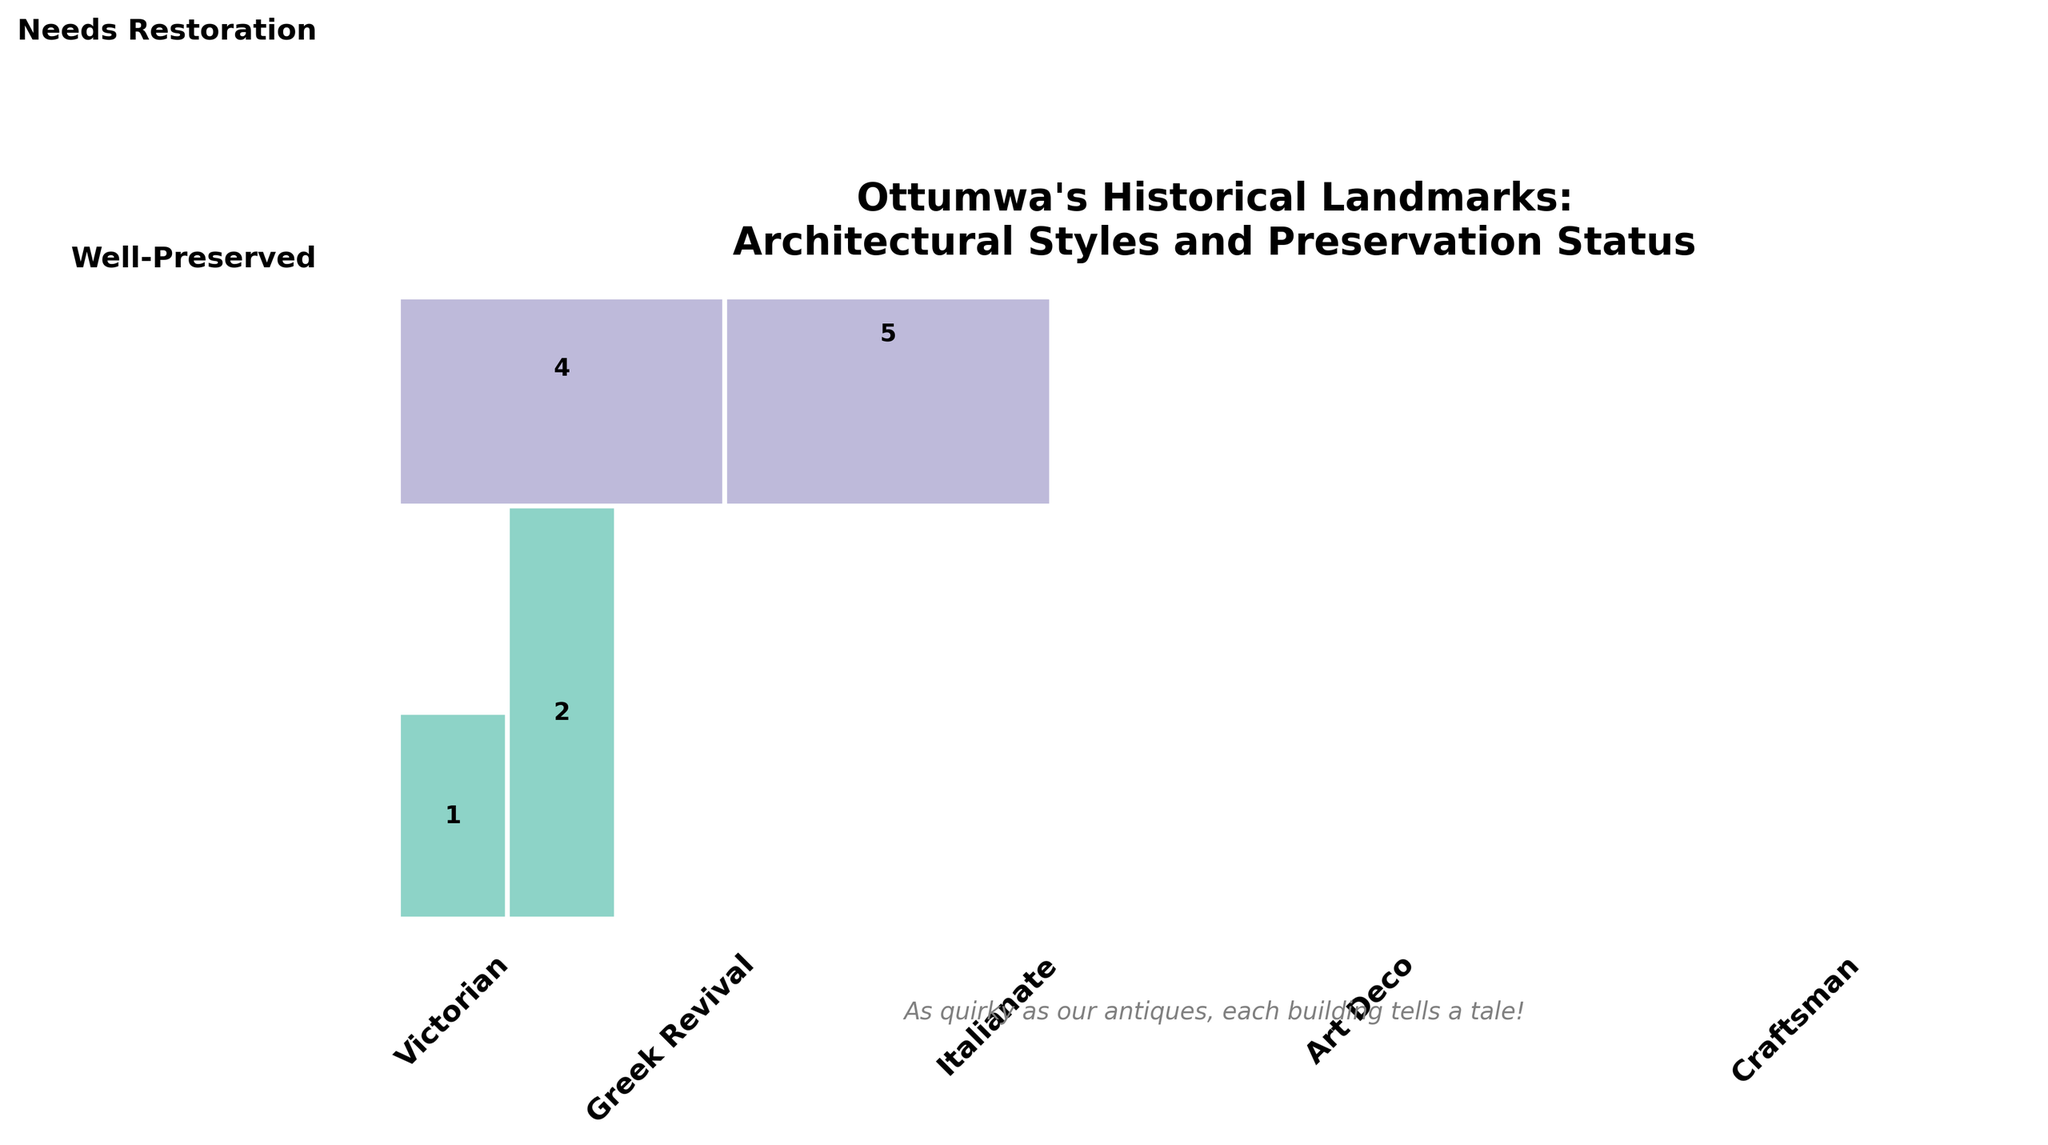What's the title of the plot? The title is usually displayed prominently at the top of the figure. In this case, the title is written in a bold and larger font size.
Answer: "Ottumwa's Historical Landmarks: Architectural Styles and Preservation Status" Which architectural style has the most landmarks that are well-preserved? To find this, look at the heights of the respective well-preserved sections for each architectural style. The tallest section for 'Well-Preserved' landmarks represents the highest count.
Answer: Victorian Which architectural style has the fewest landmarks needing restoration? Identify the shortest section among the 'Needs Restoration' categories for each architectural style. The shortest section will indicate the fewest landmarks needing restoration.
Answer: Art Deco How many total landmarks are there? To get the total number of landmarks, sum the counts from both preservation statuses across all architectural styles. Summing up (8 + 5 + 6 + 3 + 4 + 7 + 2 + 1 + 5 + 4) = 45.
Answer: 45 Which preservation status has the higher total landmark count? Sum the counts of landmarks for 'Well-Preserved' and 'Needs Restoration' statuses separately. Compare them to see which sum is higher. Well-Preserved has: 8 + 6 + 4 + 2 + 5 =25. Needs Restoration has: 5 + 3 + 7 + 1 + 4 = 20.
Answer: Well-Preserved What is the proportion of Victorian landmarks among all landmarks? Calculate the number of Victorian landmarks (both well-preserved and needing restoration) and divide it by the total landmarks. 13 (8 + 5) Victorians out of 45 total landmarks: 13/45 ≈ 0.289.
Answer: ≈ 0.289 Which architectural style shows the largest difference in the number of well-preserved vs. needing restoration? Calculate the difference for each architectural style by subtracting the count of 'Needs Restoration' from 'Well-Preserved' and vice versa. The largest absolute difference indicates the greatest disparity. Victorian has a difference of 3 (8-5), Greek Revival has 3 (6-3), Italianate has 3 (4-7), Art Deco has 1 (2-1), and Craftsman has 1 (5-4). None have a larger difference.
Answer: No single largest difference How many Greek Revival landmarks are there in total? Sum the counts of both well-preserved and needing restoration Greek Revival landmarks. 6 well-preserved + 3 needing restoration = 9.
Answer: 9 Which category, by landmark count, is the smallest on the plot? Compare the individual counts for all combinations of architectural styles and preservation statuses. The smallest count is identified by the corresponding rectangle with the smallest height.
Answer: Art Deco, Needs Restoration, Count of 1 